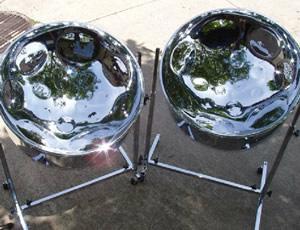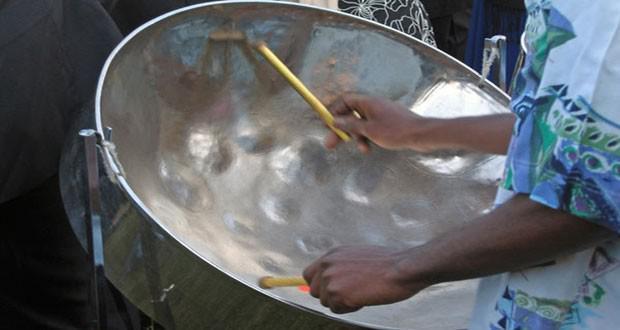The first image is the image on the left, the second image is the image on the right. Given the left and right images, does the statement "Two hands belonging to someone wearing a hawaiaan shirt are holding drumsticks over the concave bowl of a steel drum in one image, and the other image shows the bowl of at least one drum with no drumsticks in it." hold true? Answer yes or no. Yes. The first image is the image on the left, the second image is the image on the right. For the images shown, is this caption "There is a total of three drums." true? Answer yes or no. Yes. 